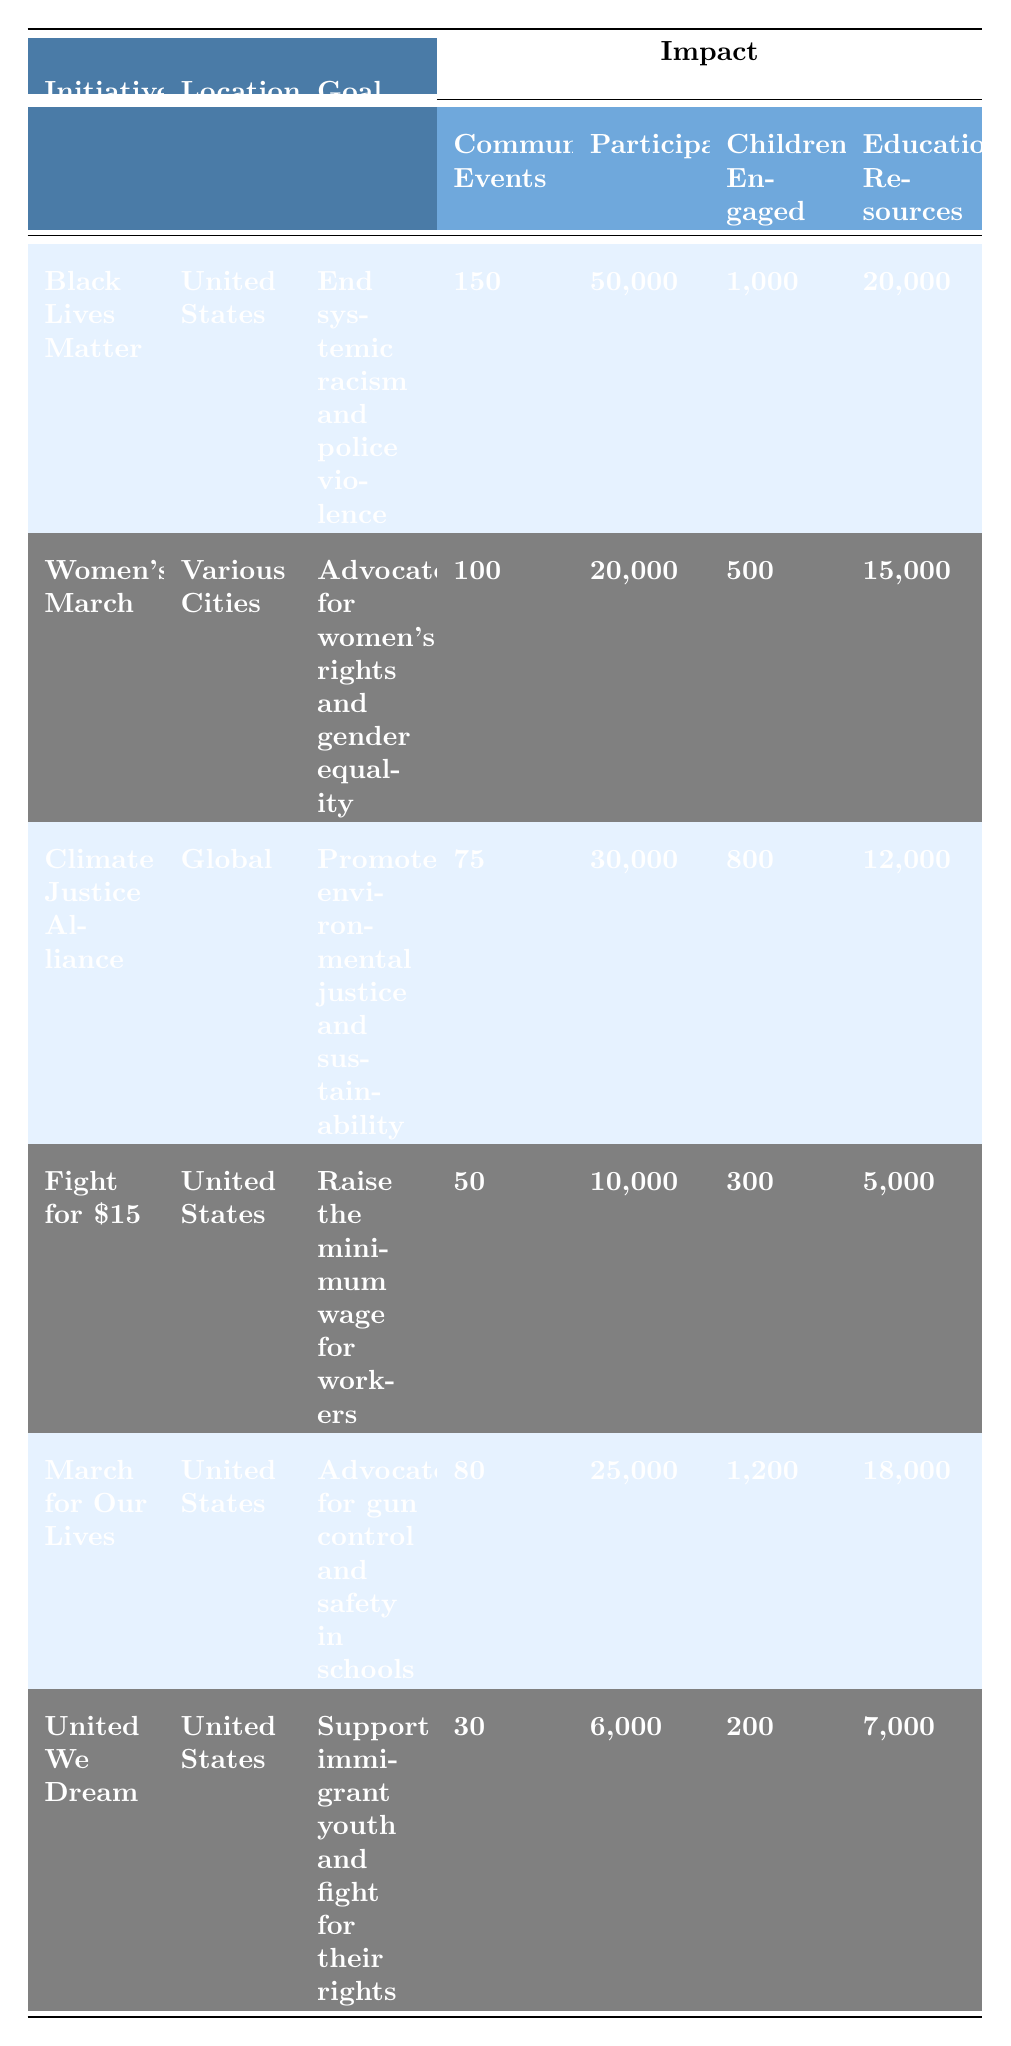What is the goal of the Black Lives Matter initiative? The table clearly states the goal associated with the Black Lives Matter initiative, which is "End systemic racism and police violence."
Answer: End systemic racism and police violence How many community events were organized by the Women's March? According to the table, the Women's March organized a total of 100 community events.
Answer: 100 Which initiative engaged the most children? From the table, the March for Our Lives engaged 1,200 children, which is the highest number compared to other initiatives listed.
Answer: March for Our Lives What is the total number of participants across all initiatives? To find the total, we sum the participants from all initiatives: 50,000 + 20,000 + 30,000 + 10,000 + 25,000 + 6,000 = 141,000 participants in total.
Answer: 141,000 Is the Climate Justice Alliance initiative focused on local or global efforts? The table specifies that the Climate Justice Alliance operates on a global scale, indicating it is a global effort.
Answer: Yes, it is global How many more educational resources were distributed by the Black Lives Matter initiative than by United We Dream? We compare the educational resources: Black Lives Matter distributed 20,000, while United We Dream distributed 7,000. So, 20,000 - 7,000 = 13,000 more resources.
Answer: 13,000 What is the average number of children engaged across all initiatives? We calculate the average by summing the number of children engaged (1,000 + 500 + 800 + 300 + 1,200 + 200 = 3,000) and dividing by the number of initiatives (3,000 / 6 = 500 children).
Answer: 500 Which initiative had the least number of community events? By examining the table, we see that United We Dream had the least, with only 30 community events organized.
Answer: United We Dream Did the March for Our Lives distribute more educational resources than the Fight for $15? The table shows that March for Our Lives distributed 18,000 educational resources while Fight for $15 distributed 5,000. Thus, March for Our Lives distributed more.
Answer: Yes What percentage of participants in the Women's March were children? To calculate the percentage, we divide the number of children engaged (500) by the total participants (20,000) and multiply by 100: (500 / 20,000) * 100 = 2.5%.
Answer: 2.5% 